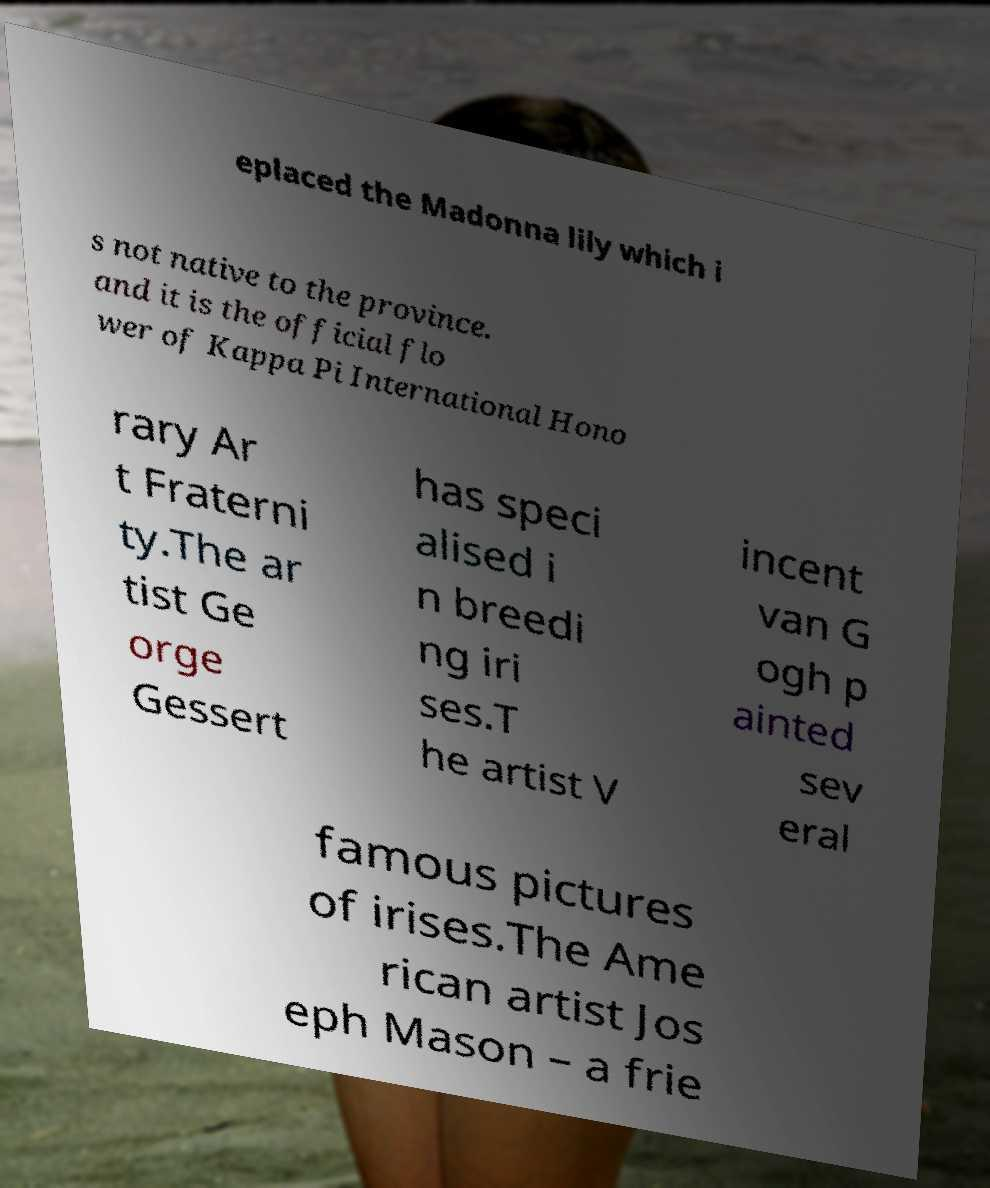There's text embedded in this image that I need extracted. Can you transcribe it verbatim? eplaced the Madonna lily which i s not native to the province. and it is the official flo wer of Kappa Pi International Hono rary Ar t Fraterni ty.The ar tist Ge orge Gessert has speci alised i n breedi ng iri ses.T he artist V incent van G ogh p ainted sev eral famous pictures of irises.The Ame rican artist Jos eph Mason – a frie 